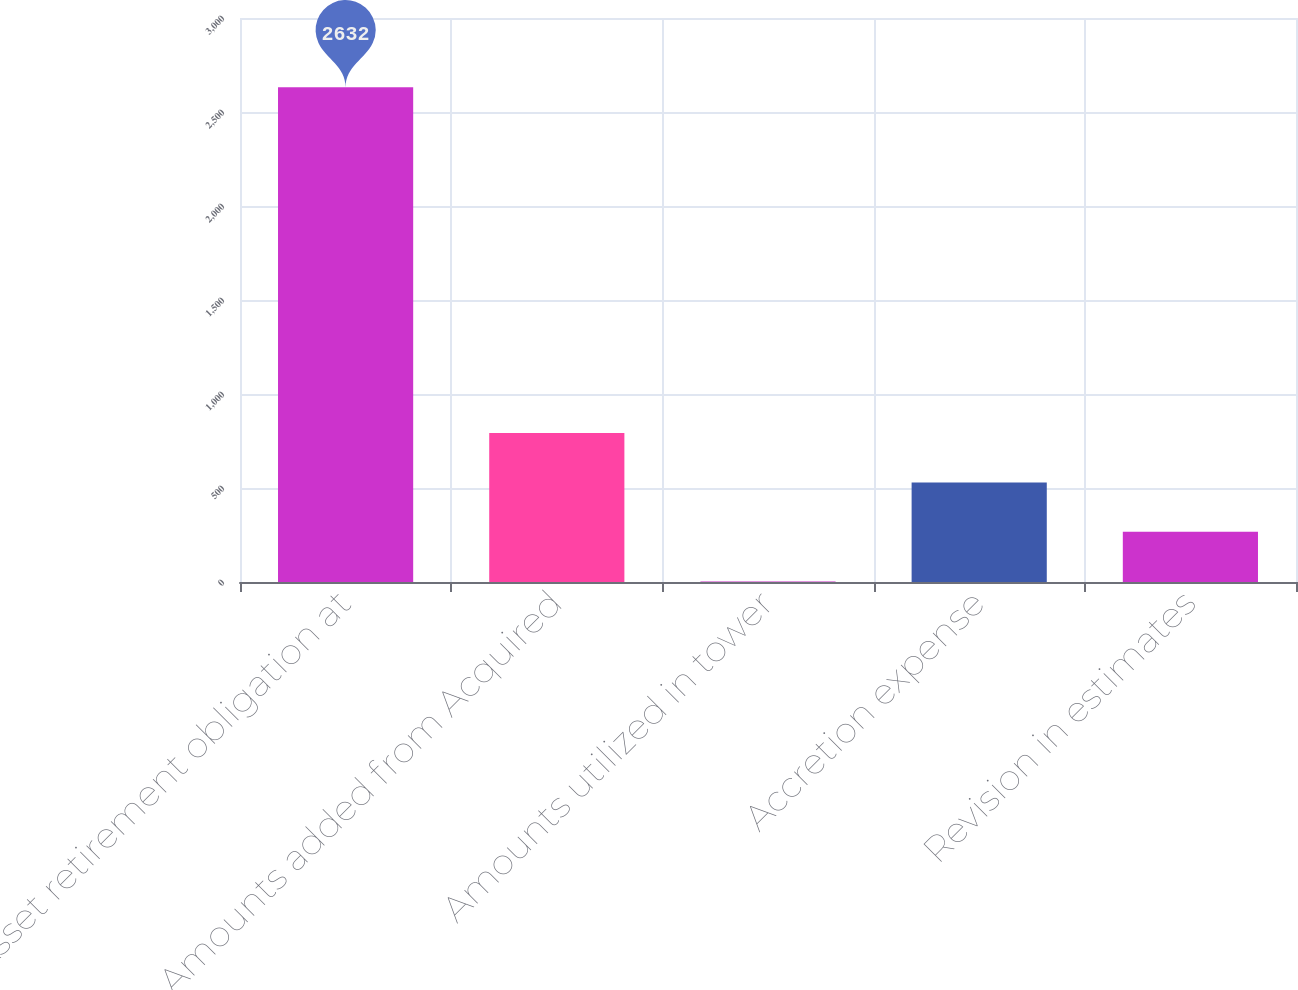Convert chart. <chart><loc_0><loc_0><loc_500><loc_500><bar_chart><fcel>Asset retirement obligation at<fcel>Amounts added from Acquired<fcel>Amounts utilized in tower<fcel>Accretion expense<fcel>Revision in estimates<nl><fcel>2632<fcel>792.4<fcel>4<fcel>529.6<fcel>266.8<nl></chart> 